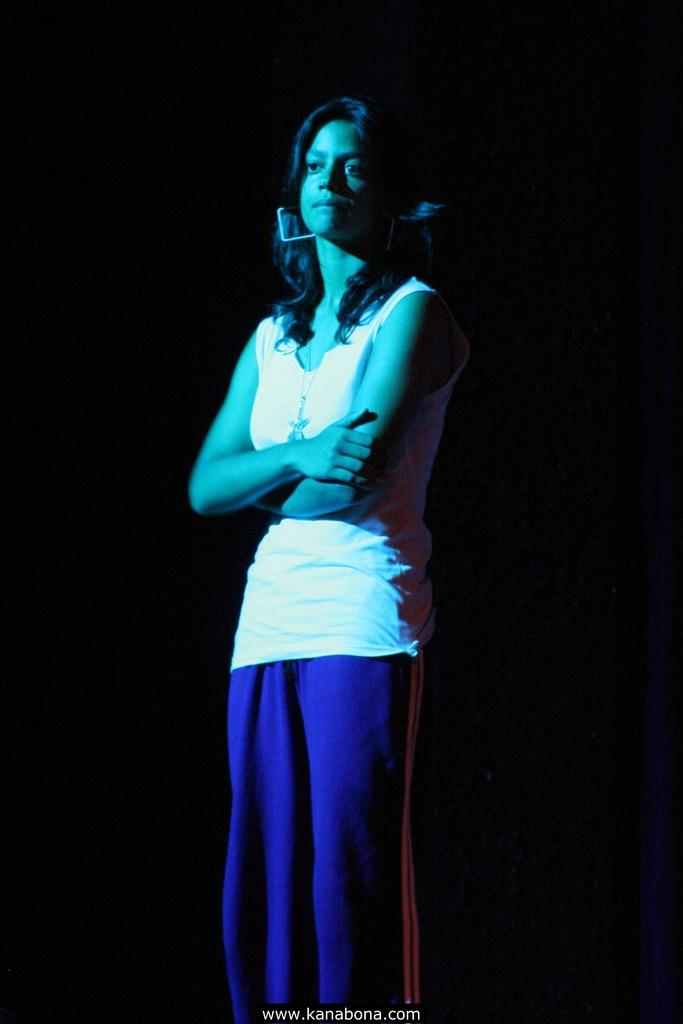Who is the main subject in the image? There is a woman in the center of the image. What is the woman wearing? The woman is wearing a white top. What color is the background of the image? The background of the image is black. Where is the text located in the image? The text is at the bottom of the image. What type of fuel is the woman using to power her car in the image? There is no car or fuel present in the image; it features a woman wearing a white top against a black background with text at the bottom. Can you tell me how many stamps are on the woman's shirt in the image? There are no stamps visible on the woman's shirt in the image. 